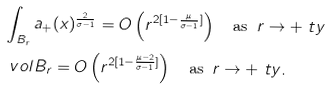Convert formula to latex. <formula><loc_0><loc_0><loc_500><loc_500>& \int _ { B _ { r } } a _ { + } ( x ) ^ { \frac { 2 } { \sigma - 1 } } = O \left ( r ^ { 2 [ 1 - \frac { \mu } { \sigma - 1 } ] } \right ) \quad \text {as } \, r \to + \ t y \\ & \ v o l B _ { r } = O \left ( r ^ { 2 [ 1 - \frac { \mu - 2 } { \sigma - 1 } ] } \right ) \quad \text {as } \, r \to + \ t y .</formula> 